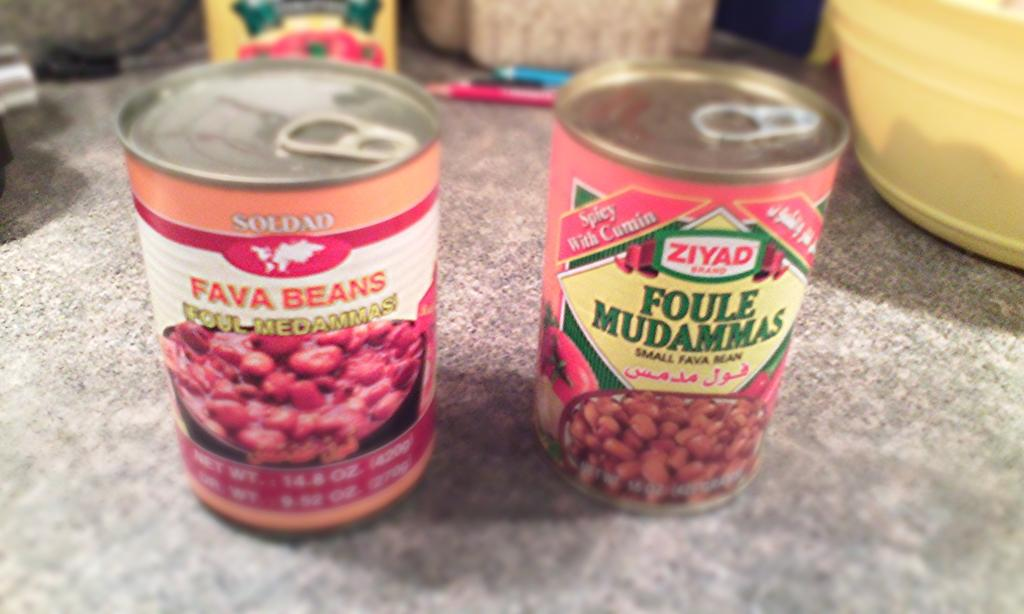<image>
Relay a brief, clear account of the picture shown. A can of SOLDAD FAVA BEANS and ZIYAD FOULE MUDAMMAS are pictured. 